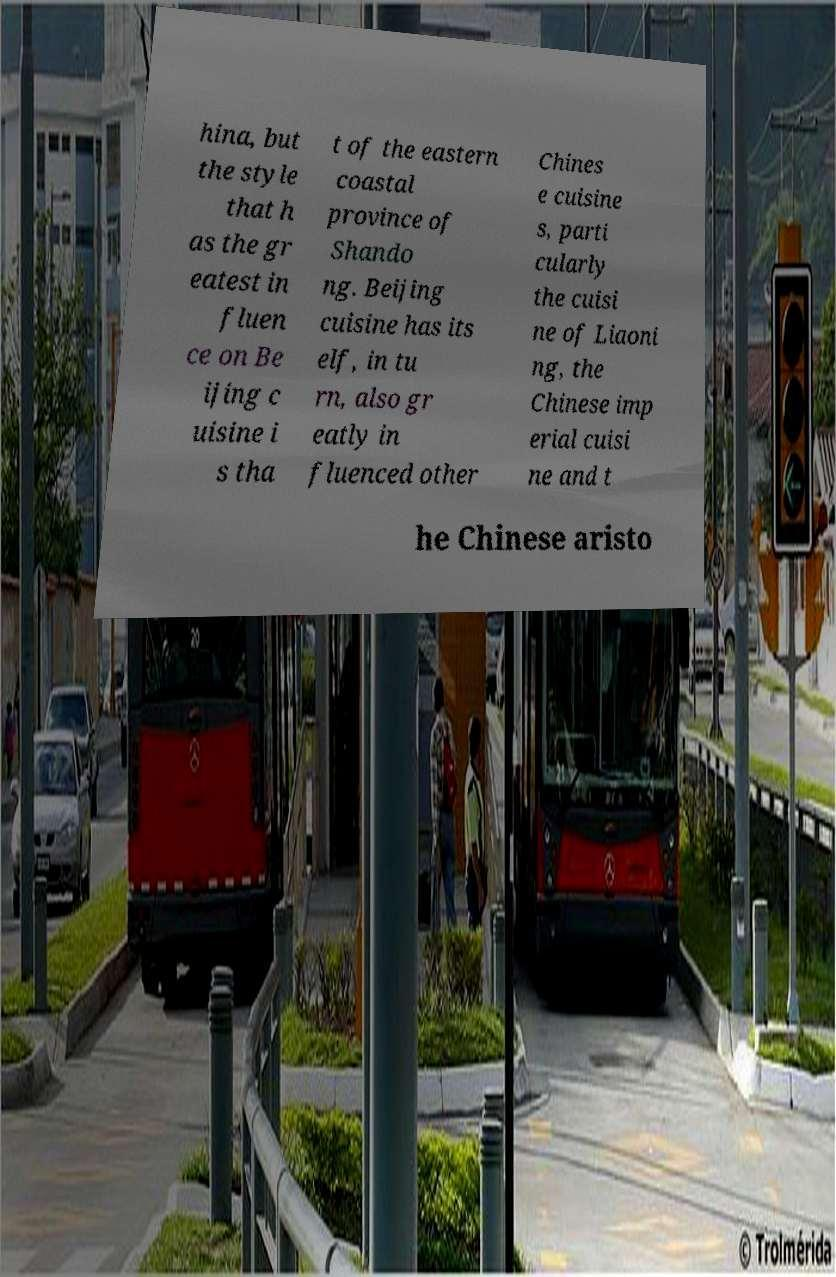Could you extract and type out the text from this image? hina, but the style that h as the gr eatest in fluen ce on Be ijing c uisine i s tha t of the eastern coastal province of Shando ng. Beijing cuisine has its elf, in tu rn, also gr eatly in fluenced other Chines e cuisine s, parti cularly the cuisi ne of Liaoni ng, the Chinese imp erial cuisi ne and t he Chinese aristo 